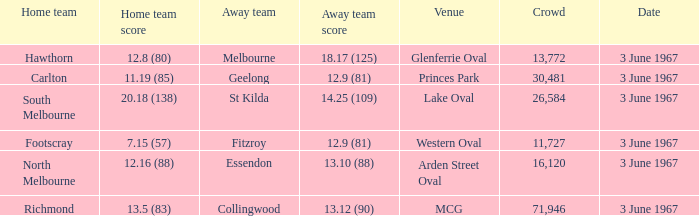Where did Geelong play as the away team? Princes Park. 